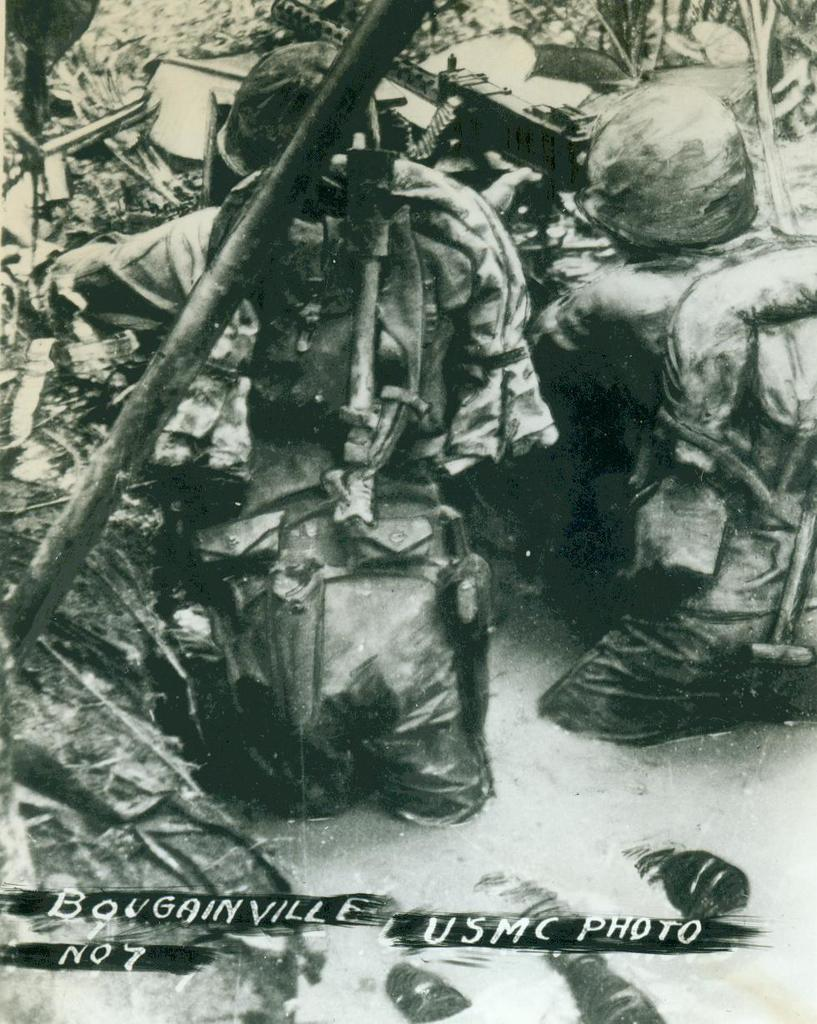What are the persons in the image doing? The persons in the image are hiding. What might be obstructing their view? Someone is blocking their view. What type of protective gear are the persons wearing? The persons are wearing helmets. What are the persons carrying with them? The persons are carrying bags. What are the persons holding in their hands? The persons are holding weapons in their hands. What can be seen at the bottom of the image? There is water visible at the bottom of the image. What type of loaf is being expanded in the image? There is no loaf or expansion present in the image. What fact can be learned from the image about the persons' ability to communicate? The image does not provide any information about the persons' ability to communicate. 